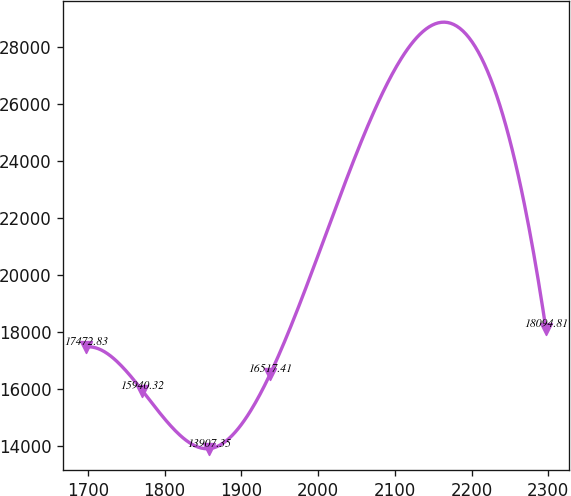Convert chart to OTSL. <chart><loc_0><loc_0><loc_500><loc_500><line_chart><ecel><fcel>Unnamed: 1<nl><fcel>1697.58<fcel>17472.8<nl><fcel>1770.96<fcel>15940.3<nl><fcel>1857.6<fcel>13907.4<nl><fcel>1937.38<fcel>16517.4<nl><fcel>2296.85<fcel>18094.8<nl></chart> 